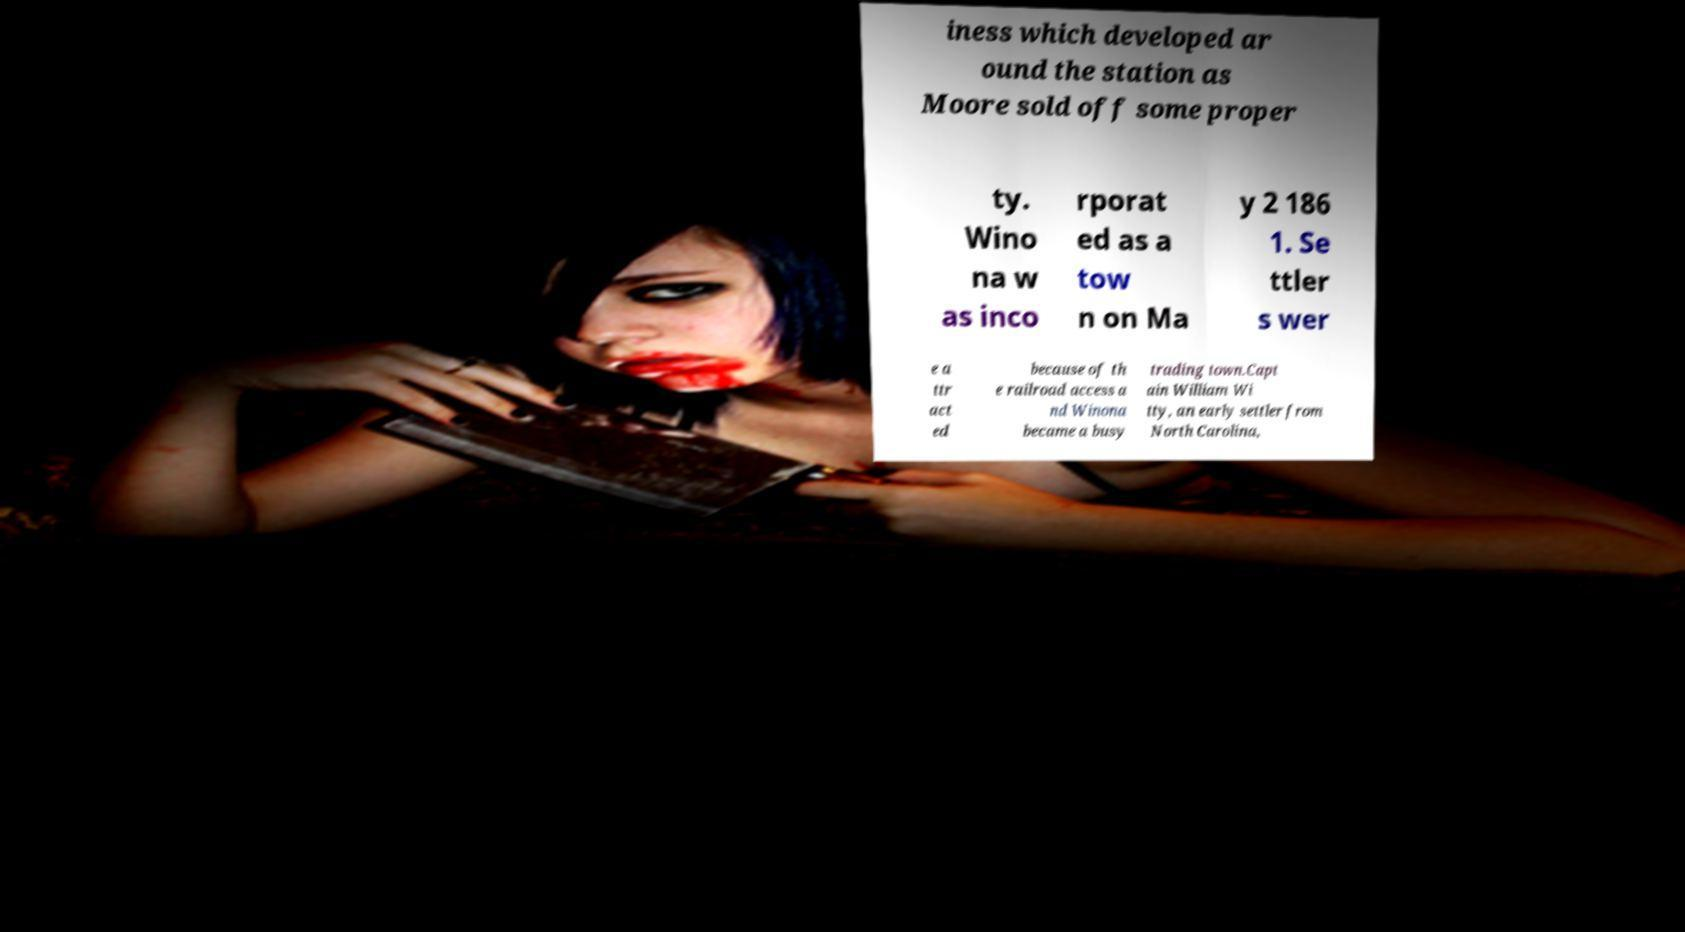What messages or text are displayed in this image? I need them in a readable, typed format. iness which developed ar ound the station as Moore sold off some proper ty. Wino na w as inco rporat ed as a tow n on Ma y 2 186 1. Se ttler s wer e a ttr act ed because of th e railroad access a nd Winona became a busy trading town.Capt ain William Wi tty, an early settler from North Carolina, 